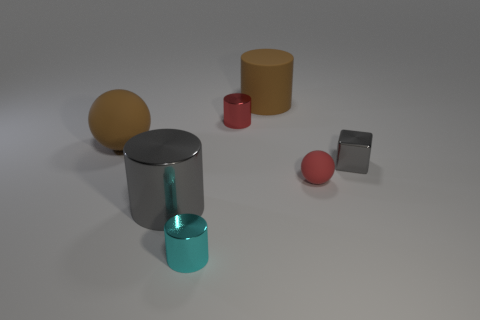There is a cyan shiny thing; how many metallic cylinders are right of it?
Keep it short and to the point. 1. How many balls are small red objects or gray shiny objects?
Keep it short and to the point. 1. There is a rubber thing that is both on the right side of the brown sphere and behind the tiny gray shiny cube; what size is it?
Offer a very short reply. Large. What number of other objects are the same color as the tiny matte object?
Keep it short and to the point. 1. Do the tiny sphere and the brown thing behind the tiny red cylinder have the same material?
Provide a short and direct response. Yes. How many objects are either metal cylinders in front of the tiny gray metal block or large things?
Provide a succinct answer. 4. There is a rubber thing that is on the right side of the large gray thing and to the left of the small sphere; what shape is it?
Your answer should be very brief. Cylinder. The other ball that is the same material as the big sphere is what size?
Ensure brevity in your answer.  Small. How many things are either rubber things to the right of the big shiny object or small metallic objects to the right of the red shiny thing?
Make the answer very short. 3. Do the gray thing in front of the gray cube and the brown matte ball have the same size?
Ensure brevity in your answer.  Yes. 